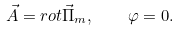<formula> <loc_0><loc_0><loc_500><loc_500>\vec { A } = r o t \vec { \Pi } _ { m } , \quad \varphi = 0 .</formula> 